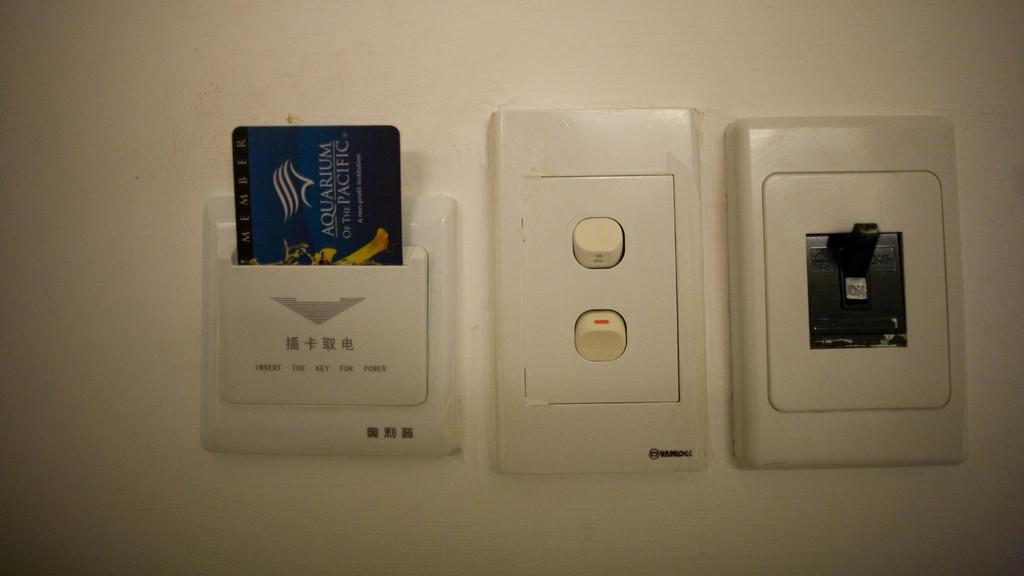What is the color of the wall in the image? The wall in the image is white. What type of object can be seen in the image that is commonly used for financial transactions? An ATM card is visible in the image. What device is present in the image that is used for managing electrical connections? There is a switchboard in the image. What time is displayed on the clock in the image? There is no clock present in the image. What type of beverage is being served in the image? There is no beverage, such as soda, present in the image. 